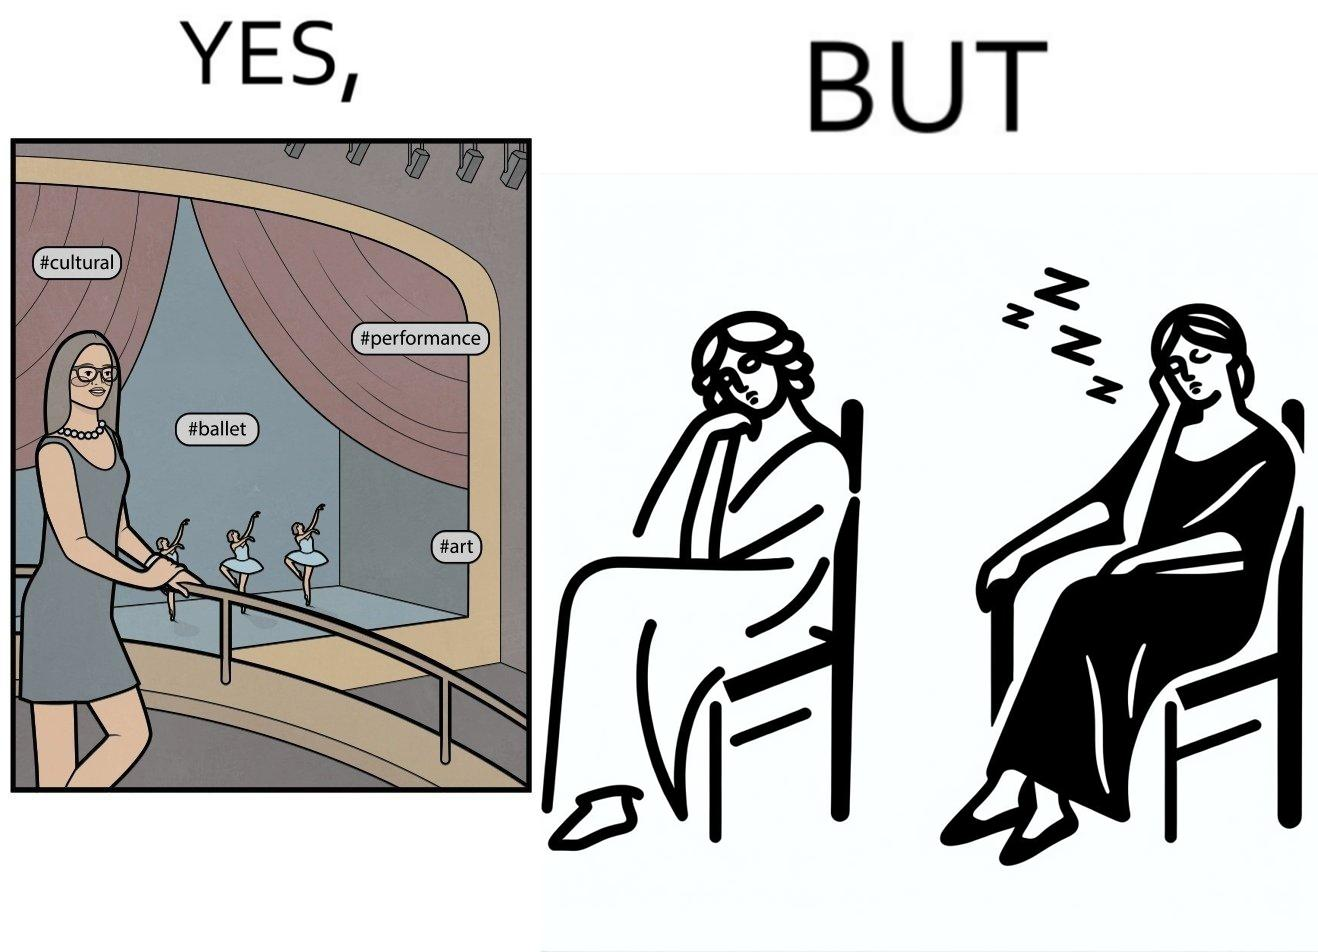Describe the content of this image. The image is ironic, because in the first image the woman is trying to show off how much she likes ballet dance performance by posting a photo attending some program but in the same program she is seen sleeping on the chair 